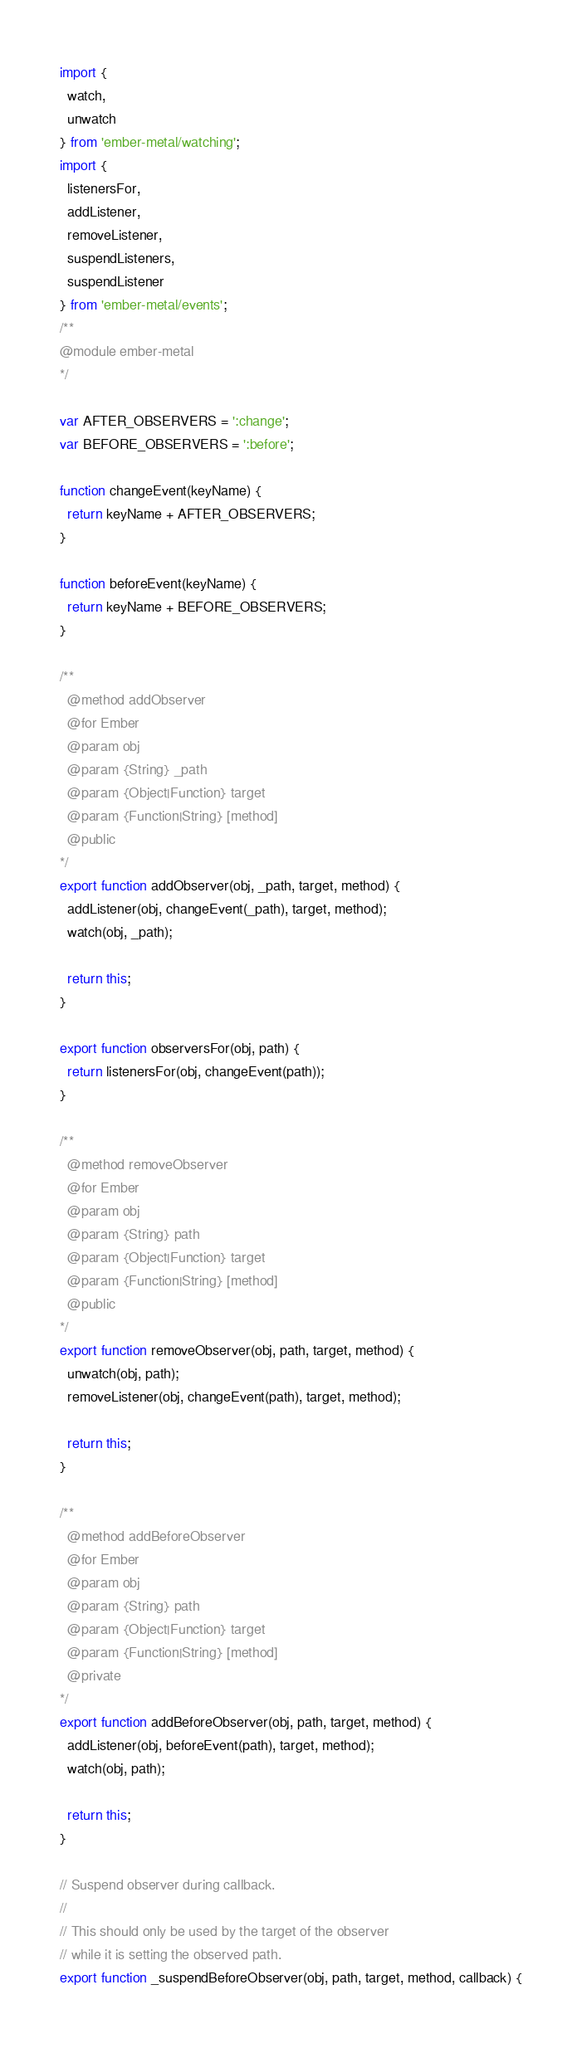<code> <loc_0><loc_0><loc_500><loc_500><_JavaScript_>import {
  watch,
  unwatch
} from 'ember-metal/watching';
import {
  listenersFor,
  addListener,
  removeListener,
  suspendListeners,
  suspendListener
} from 'ember-metal/events';
/**
@module ember-metal
*/

var AFTER_OBSERVERS = ':change';
var BEFORE_OBSERVERS = ':before';

function changeEvent(keyName) {
  return keyName + AFTER_OBSERVERS;
}

function beforeEvent(keyName) {
  return keyName + BEFORE_OBSERVERS;
}

/**
  @method addObserver
  @for Ember
  @param obj
  @param {String} _path
  @param {Object|Function} target
  @param {Function|String} [method]
  @public
*/
export function addObserver(obj, _path, target, method) {
  addListener(obj, changeEvent(_path), target, method);
  watch(obj, _path);

  return this;
}

export function observersFor(obj, path) {
  return listenersFor(obj, changeEvent(path));
}

/**
  @method removeObserver
  @for Ember
  @param obj
  @param {String} path
  @param {Object|Function} target
  @param {Function|String} [method]
  @public
*/
export function removeObserver(obj, path, target, method) {
  unwatch(obj, path);
  removeListener(obj, changeEvent(path), target, method);

  return this;
}

/**
  @method addBeforeObserver
  @for Ember
  @param obj
  @param {String} path
  @param {Object|Function} target
  @param {Function|String} [method]
  @private
*/
export function addBeforeObserver(obj, path, target, method) {
  addListener(obj, beforeEvent(path), target, method);
  watch(obj, path);

  return this;
}

// Suspend observer during callback.
//
// This should only be used by the target of the observer
// while it is setting the observed path.
export function _suspendBeforeObserver(obj, path, target, method, callback) {</code> 